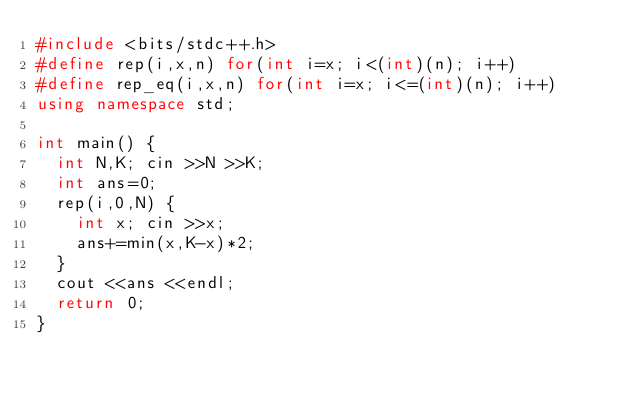Convert code to text. <code><loc_0><loc_0><loc_500><loc_500><_C++_>#include <bits/stdc++.h>
#define rep(i,x,n) for(int i=x; i<(int)(n); i++)
#define rep_eq(i,x,n) for(int i=x; i<=(int)(n); i++)
using namespace std;

int main() {
  int N,K; cin >>N >>K;
  int ans=0;
  rep(i,0,N) {
    int x; cin >>x;
    ans+=min(x,K-x)*2;
  }
  cout <<ans <<endl;
  return 0;
}
</code> 